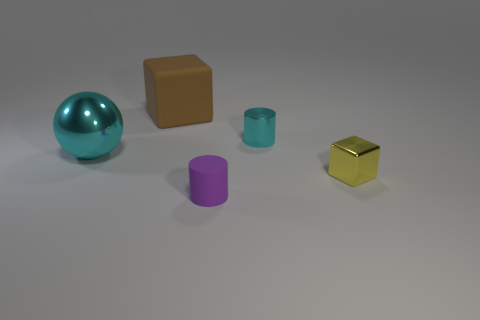Add 4 brown matte blocks. How many objects exist? 9 Subtract all balls. How many objects are left? 4 Add 3 yellow objects. How many yellow objects exist? 4 Subtract 0 red spheres. How many objects are left? 5 Subtract all metal things. Subtract all small yellow rubber spheres. How many objects are left? 2 Add 4 big cyan spheres. How many big cyan spheres are left? 5 